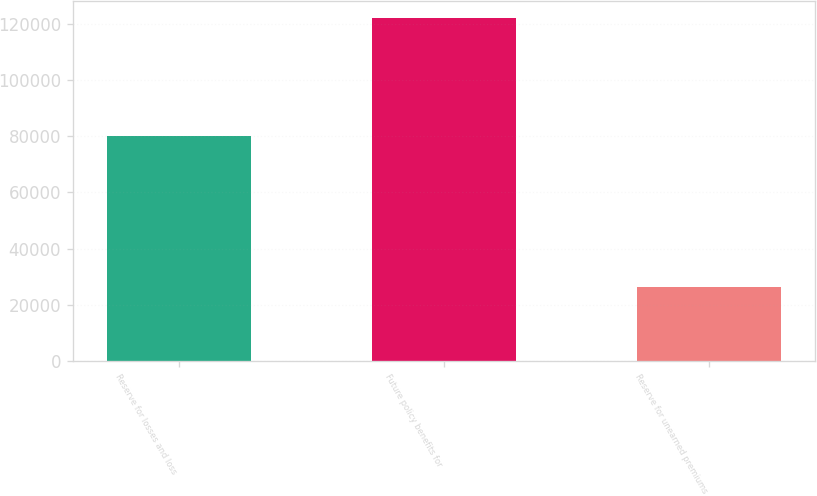Convert chart. <chart><loc_0><loc_0><loc_500><loc_500><bar_chart><fcel>Reserve for losses and loss<fcel>Future policy benefits for<fcel>Reserve for unearned premiums<nl><fcel>79999<fcel>122230<fcel>26271<nl></chart> 